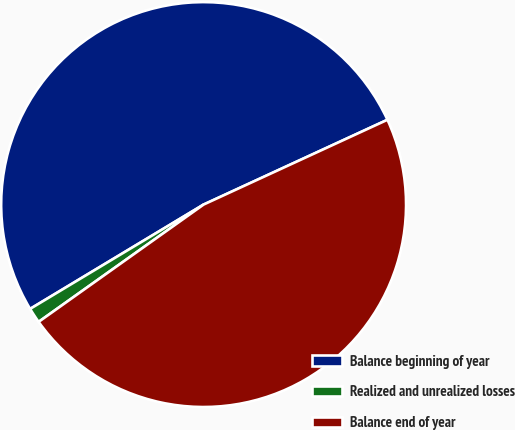Convert chart to OTSL. <chart><loc_0><loc_0><loc_500><loc_500><pie_chart><fcel>Balance beginning of year<fcel>Realized and unrealized losses<fcel>Balance end of year<nl><fcel>51.74%<fcel>1.22%<fcel>47.04%<nl></chart> 